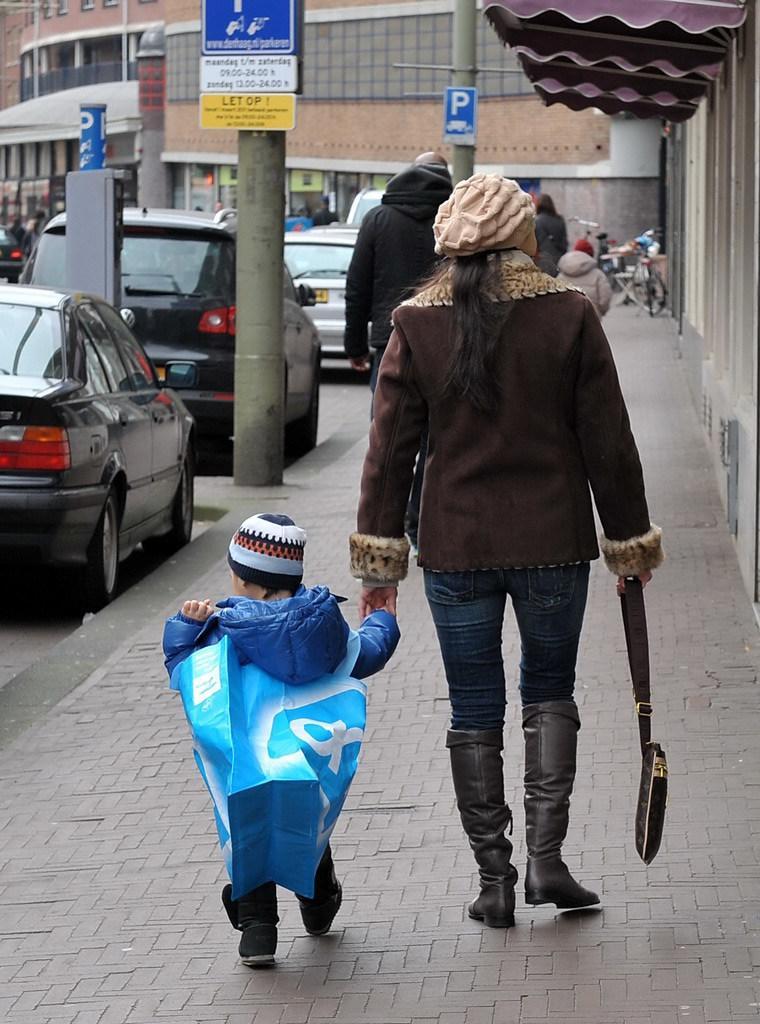How would you summarize this image in a sentence or two? In this picture we can see there are groups of people on the walkway. On the left side of the people, there are vehicles and there are poles with boards. In front of the vehicles, there are buildings. In front of the people, there is a bicycle and some objects. 